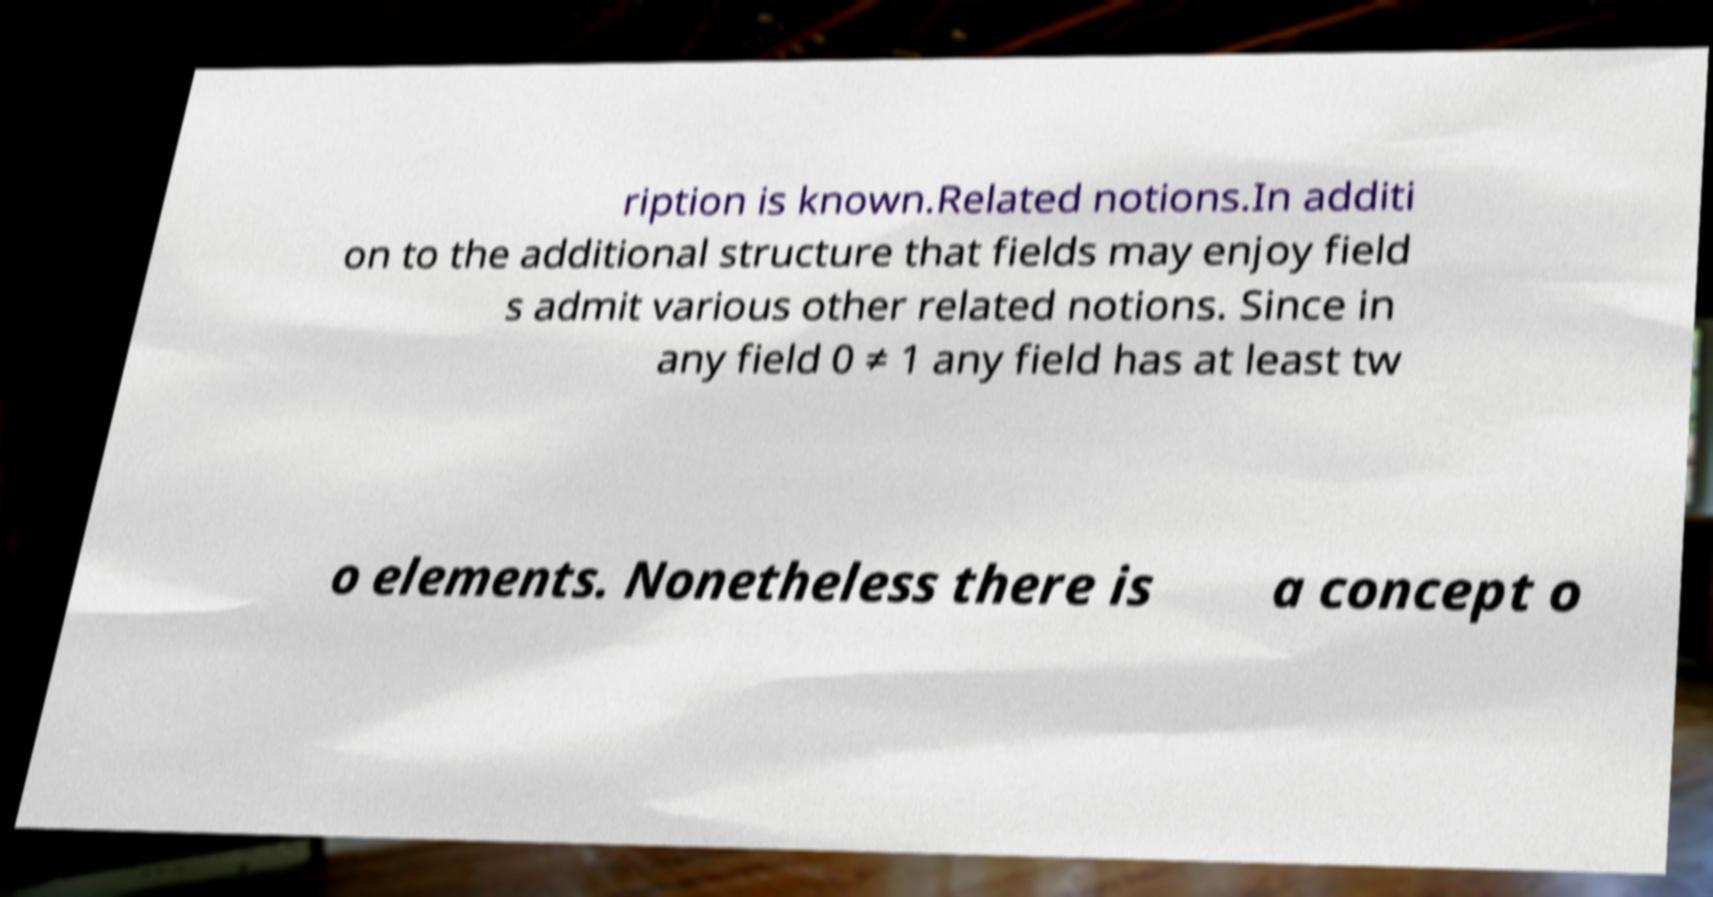I need the written content from this picture converted into text. Can you do that? ription is known.Related notions.In additi on to the additional structure that fields may enjoy field s admit various other related notions. Since in any field 0 ≠ 1 any field has at least tw o elements. Nonetheless there is a concept o 